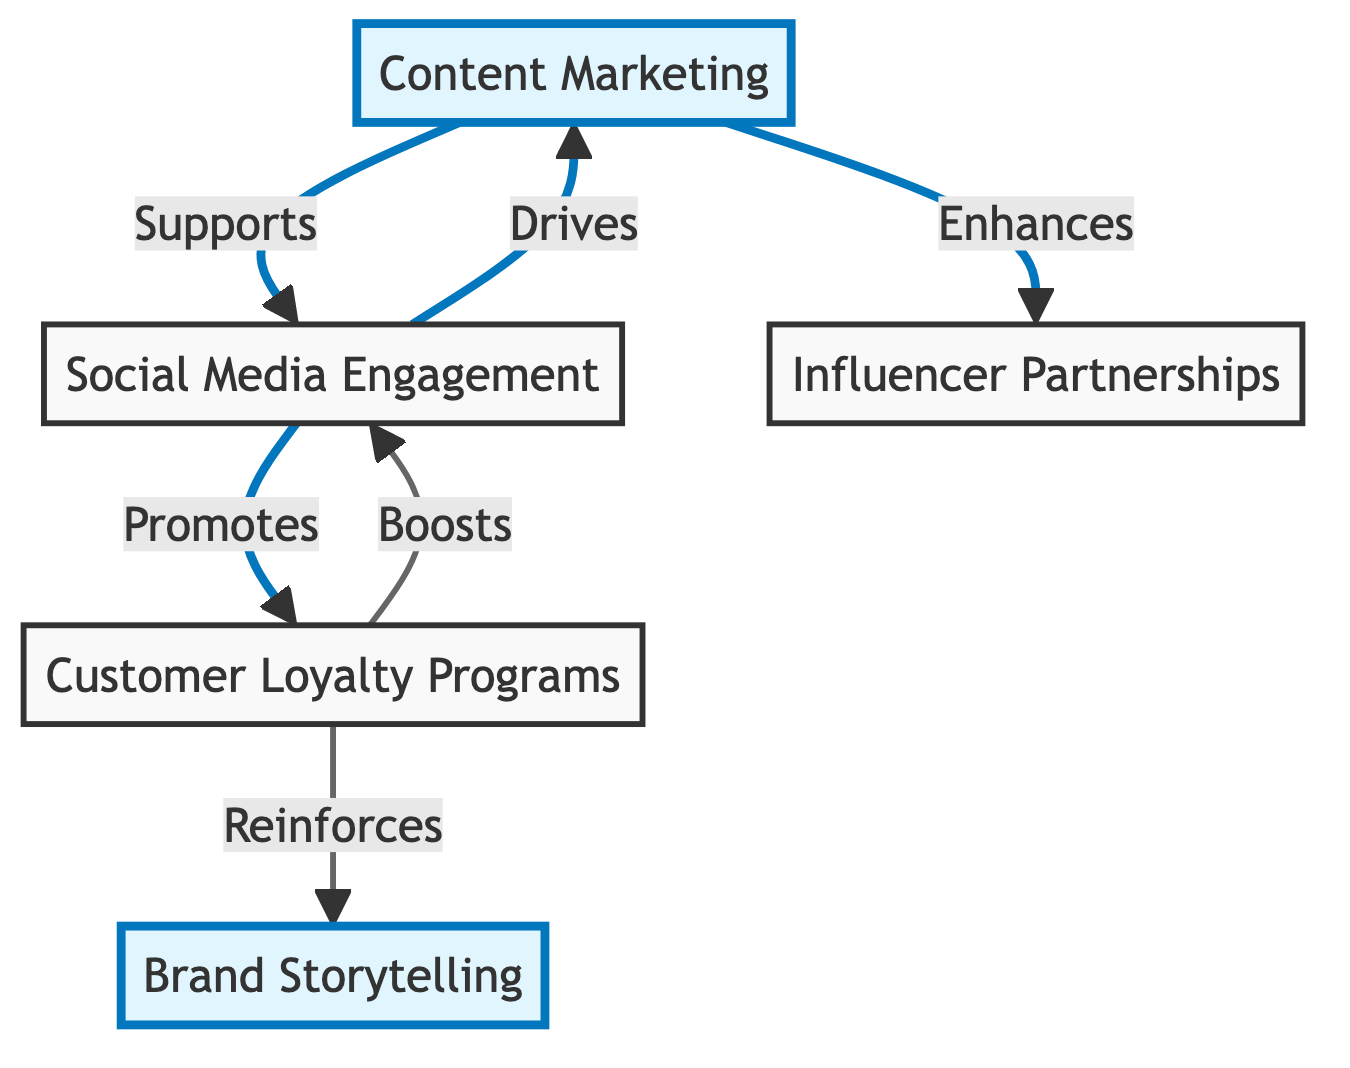What's the total number of initiatives in the diagram? The diagram lists five initiatives: Content Marketing, Social Media Engagement, Influencer Partnerships, Customer Loyalty Programs, and Brand Storytelling. Therefore, adding them up gives a total of five initiatives.
Answer: Five Which initiative drives Social Media Engagement? The arrow directed from Content Marketing to Social Media Engagement indicates that Content Marketing drives Social Media Engagement.
Answer: Content Marketing How many dependencies does Influencer Partnerships have? The node for Influencer Partnerships has no outgoing edges indicating dependencies, which means it has zero dependencies.
Answer: Zero What initiative supports Customer Loyalty Programs? The directed edge from Social Media Engagement to Customer Loyalty Programs shows that Social Media Engagement supports Customer Loyalty Programs.
Answer: Social Media Engagement Which initiative is being reinforced by Customer Loyalty Programs? The diagram shows an arrow from Customer Loyalty Programs to Brand Storytelling, indicating that Customer Loyalty Programs reinforce Brand Storytelling.
Answer: Brand Storytelling What is the relationship between Content Marketing and Influencer Partnerships? The edge heading from Content Marketing to Influencer Partnerships suggests that Content Marketing enhances the impact of Influencer Partnerships, creating a supportive relationship between them.
Answer: Enhances How many edges are in the graph? By counting the directed edges: Content Marketing to Social Media Engagement (1), Content Marketing to Influencer Partnerships (2), Social Media Engagement to Content Marketing (3), Social Media Engagement to Customer Loyalty Programs (4), Customer Loyalty Programs to Social Media Engagement (5), and Customer Loyalty Programs to Brand Storytelling (6), we arrive at a total of six edges.
Answer: Six Which initiative promotes Customer Loyalty Programs? The directed relationship from Social Media Engagement to Customer Loyalty Programs indicates that Social Media Engagement promotes Customer Loyalty Programs.
Answer: Social Media Engagement What is the direct effect of Customer Loyalty Programs on Brand Storytelling? The effect is a reinforcing one, as indicated by the arrow from Customer Loyalty Programs to Brand Storytelling in the diagram.
Answer: Reinforces 